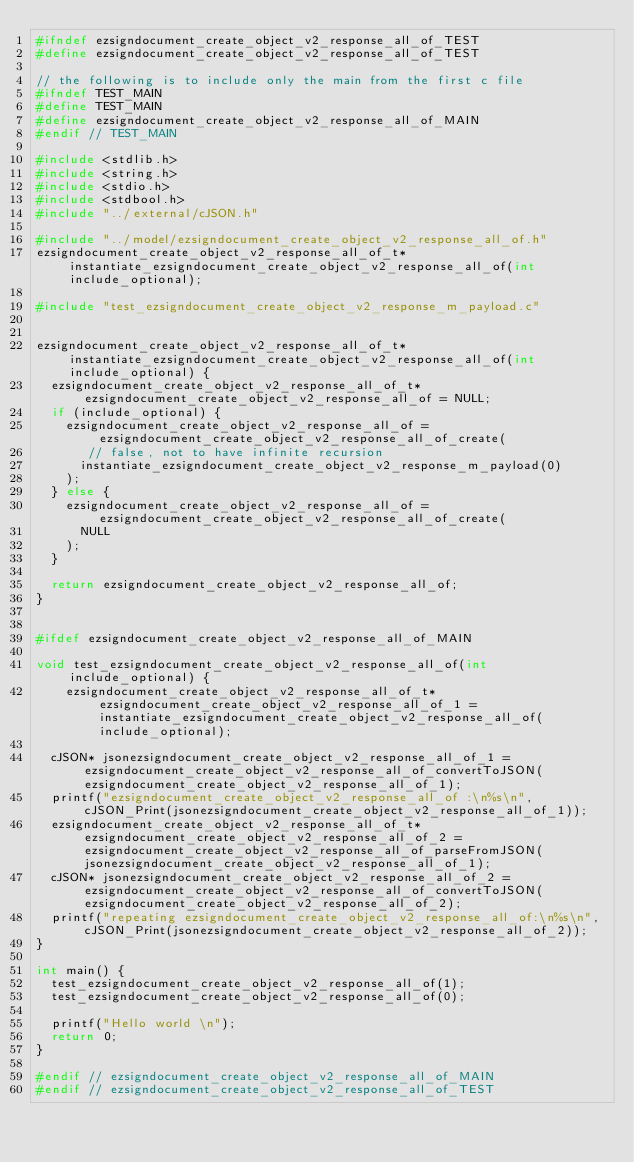<code> <loc_0><loc_0><loc_500><loc_500><_C_>#ifndef ezsigndocument_create_object_v2_response_all_of_TEST
#define ezsigndocument_create_object_v2_response_all_of_TEST

// the following is to include only the main from the first c file
#ifndef TEST_MAIN
#define TEST_MAIN
#define ezsigndocument_create_object_v2_response_all_of_MAIN
#endif // TEST_MAIN

#include <stdlib.h>
#include <string.h>
#include <stdio.h>
#include <stdbool.h>
#include "../external/cJSON.h"

#include "../model/ezsigndocument_create_object_v2_response_all_of.h"
ezsigndocument_create_object_v2_response_all_of_t* instantiate_ezsigndocument_create_object_v2_response_all_of(int include_optional);

#include "test_ezsigndocument_create_object_v2_response_m_payload.c"


ezsigndocument_create_object_v2_response_all_of_t* instantiate_ezsigndocument_create_object_v2_response_all_of(int include_optional) {
  ezsigndocument_create_object_v2_response_all_of_t* ezsigndocument_create_object_v2_response_all_of = NULL;
  if (include_optional) {
    ezsigndocument_create_object_v2_response_all_of = ezsigndocument_create_object_v2_response_all_of_create(
       // false, not to have infinite recursion
      instantiate_ezsigndocument_create_object_v2_response_m_payload(0)
    );
  } else {
    ezsigndocument_create_object_v2_response_all_of = ezsigndocument_create_object_v2_response_all_of_create(
      NULL
    );
  }

  return ezsigndocument_create_object_v2_response_all_of;
}


#ifdef ezsigndocument_create_object_v2_response_all_of_MAIN

void test_ezsigndocument_create_object_v2_response_all_of(int include_optional) {
    ezsigndocument_create_object_v2_response_all_of_t* ezsigndocument_create_object_v2_response_all_of_1 = instantiate_ezsigndocument_create_object_v2_response_all_of(include_optional);

	cJSON* jsonezsigndocument_create_object_v2_response_all_of_1 = ezsigndocument_create_object_v2_response_all_of_convertToJSON(ezsigndocument_create_object_v2_response_all_of_1);
	printf("ezsigndocument_create_object_v2_response_all_of :\n%s\n", cJSON_Print(jsonezsigndocument_create_object_v2_response_all_of_1));
	ezsigndocument_create_object_v2_response_all_of_t* ezsigndocument_create_object_v2_response_all_of_2 = ezsigndocument_create_object_v2_response_all_of_parseFromJSON(jsonezsigndocument_create_object_v2_response_all_of_1);
	cJSON* jsonezsigndocument_create_object_v2_response_all_of_2 = ezsigndocument_create_object_v2_response_all_of_convertToJSON(ezsigndocument_create_object_v2_response_all_of_2);
	printf("repeating ezsigndocument_create_object_v2_response_all_of:\n%s\n", cJSON_Print(jsonezsigndocument_create_object_v2_response_all_of_2));
}

int main() {
  test_ezsigndocument_create_object_v2_response_all_of(1);
  test_ezsigndocument_create_object_v2_response_all_of(0);

  printf("Hello world \n");
  return 0;
}

#endif // ezsigndocument_create_object_v2_response_all_of_MAIN
#endif // ezsigndocument_create_object_v2_response_all_of_TEST
</code> 